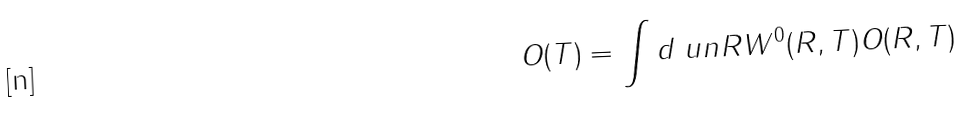Convert formula to latex. <formula><loc_0><loc_0><loc_500><loc_500>O ( T ) = \int d { \ u n R } W ^ { 0 } ( R , T ) O ( R , T )</formula> 